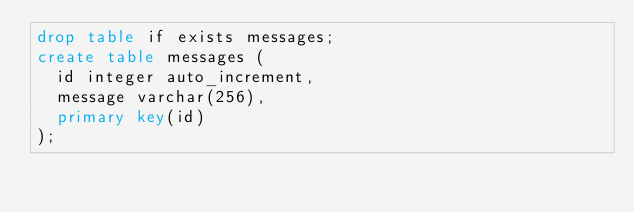<code> <loc_0><loc_0><loc_500><loc_500><_SQL_>drop table if exists messages;
create table messages (
  id integer auto_increment,
  message varchar(256),
  primary key(id)
);
</code> 